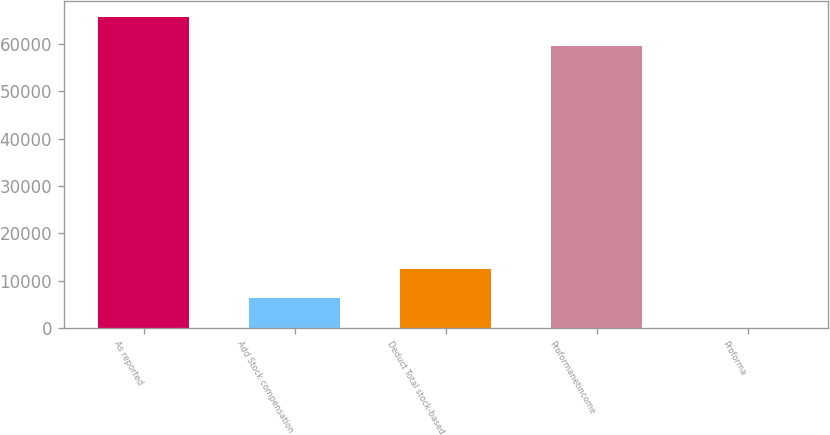Convert chart. <chart><loc_0><loc_0><loc_500><loc_500><bar_chart><fcel>As reported<fcel>Add Stock compensation<fcel>Deduct Total stock-based<fcel>Proformanetincome<fcel>Proforma<nl><fcel>65742.1<fcel>6245.73<fcel>12489.9<fcel>59498<fcel>1.59<nl></chart> 